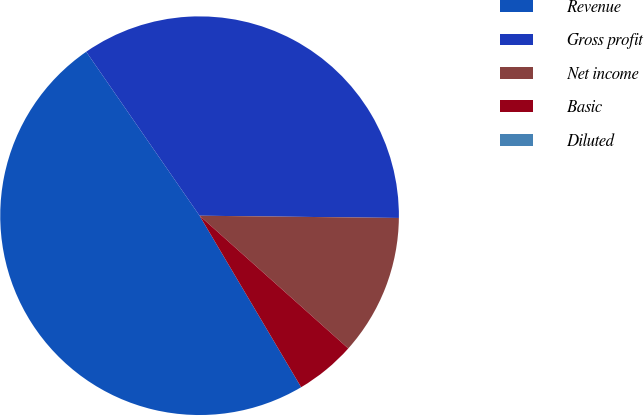Convert chart to OTSL. <chart><loc_0><loc_0><loc_500><loc_500><pie_chart><fcel>Revenue<fcel>Gross profit<fcel>Net income<fcel>Basic<fcel>Diluted<nl><fcel>48.89%<fcel>34.81%<fcel>11.42%<fcel>4.89%<fcel>0.0%<nl></chart> 